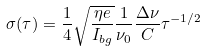<formula> <loc_0><loc_0><loc_500><loc_500>\sigma ( \tau ) = \frac { 1 } { 4 } \sqrt { \frac { \eta e } { I _ { b g } } } \frac { 1 } { \nu _ { 0 } } \frac { \Delta \nu } { C } \tau ^ { - 1 / 2 }</formula> 